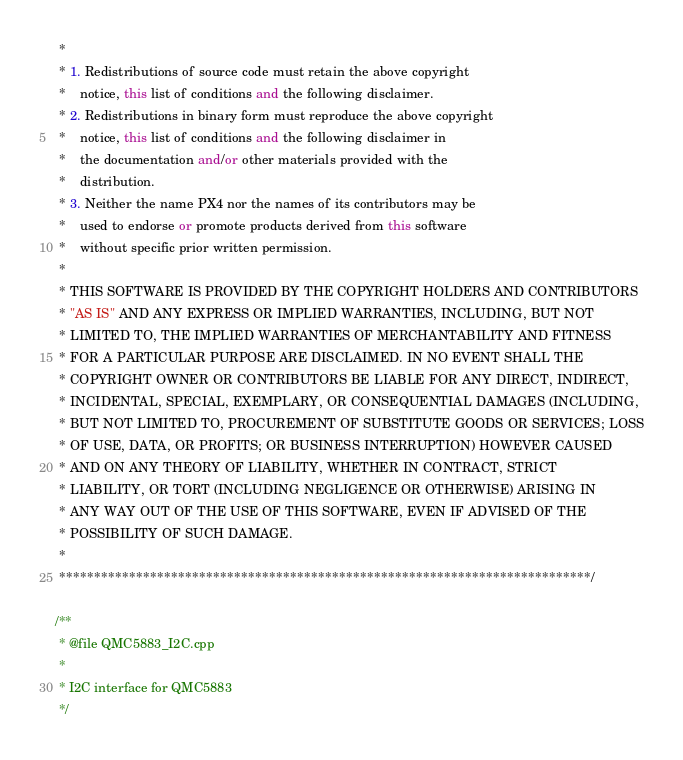Convert code to text. <code><loc_0><loc_0><loc_500><loc_500><_C++_> *
 * 1. Redistributions of source code must retain the above copyright
 *    notice, this list of conditions and the following disclaimer.
 * 2. Redistributions in binary form must reproduce the above copyright
 *    notice, this list of conditions and the following disclaimer in
 *    the documentation and/or other materials provided with the
 *    distribution.
 * 3. Neither the name PX4 nor the names of its contributors may be
 *    used to endorse or promote products derived from this software
 *    without specific prior written permission.
 *
 * THIS SOFTWARE IS PROVIDED BY THE COPYRIGHT HOLDERS AND CONTRIBUTORS
 * "AS IS" AND ANY EXPRESS OR IMPLIED WARRANTIES, INCLUDING, BUT NOT
 * LIMITED TO, THE IMPLIED WARRANTIES OF MERCHANTABILITY AND FITNESS
 * FOR A PARTICULAR PURPOSE ARE DISCLAIMED. IN NO EVENT SHALL THE
 * COPYRIGHT OWNER OR CONTRIBUTORS BE LIABLE FOR ANY DIRECT, INDIRECT,
 * INCIDENTAL, SPECIAL, EXEMPLARY, OR CONSEQUENTIAL DAMAGES (INCLUDING,
 * BUT NOT LIMITED TO, PROCUREMENT OF SUBSTITUTE GOODS OR SERVICES; LOSS
 * OF USE, DATA, OR PROFITS; OR BUSINESS INTERRUPTION) HOWEVER CAUSED
 * AND ON ANY THEORY OF LIABILITY, WHETHER IN CONTRACT, STRICT
 * LIABILITY, OR TORT (INCLUDING NEGLIGENCE OR OTHERWISE) ARISING IN
 * ANY WAY OUT OF THE USE OF THIS SOFTWARE, EVEN IF ADVISED OF THE
 * POSSIBILITY OF SUCH DAMAGE.
 *
 ****************************************************************************/

/**
 * @file QMC5883_I2C.cpp
 *
 * I2C interface for QMC5883
 */
</code> 